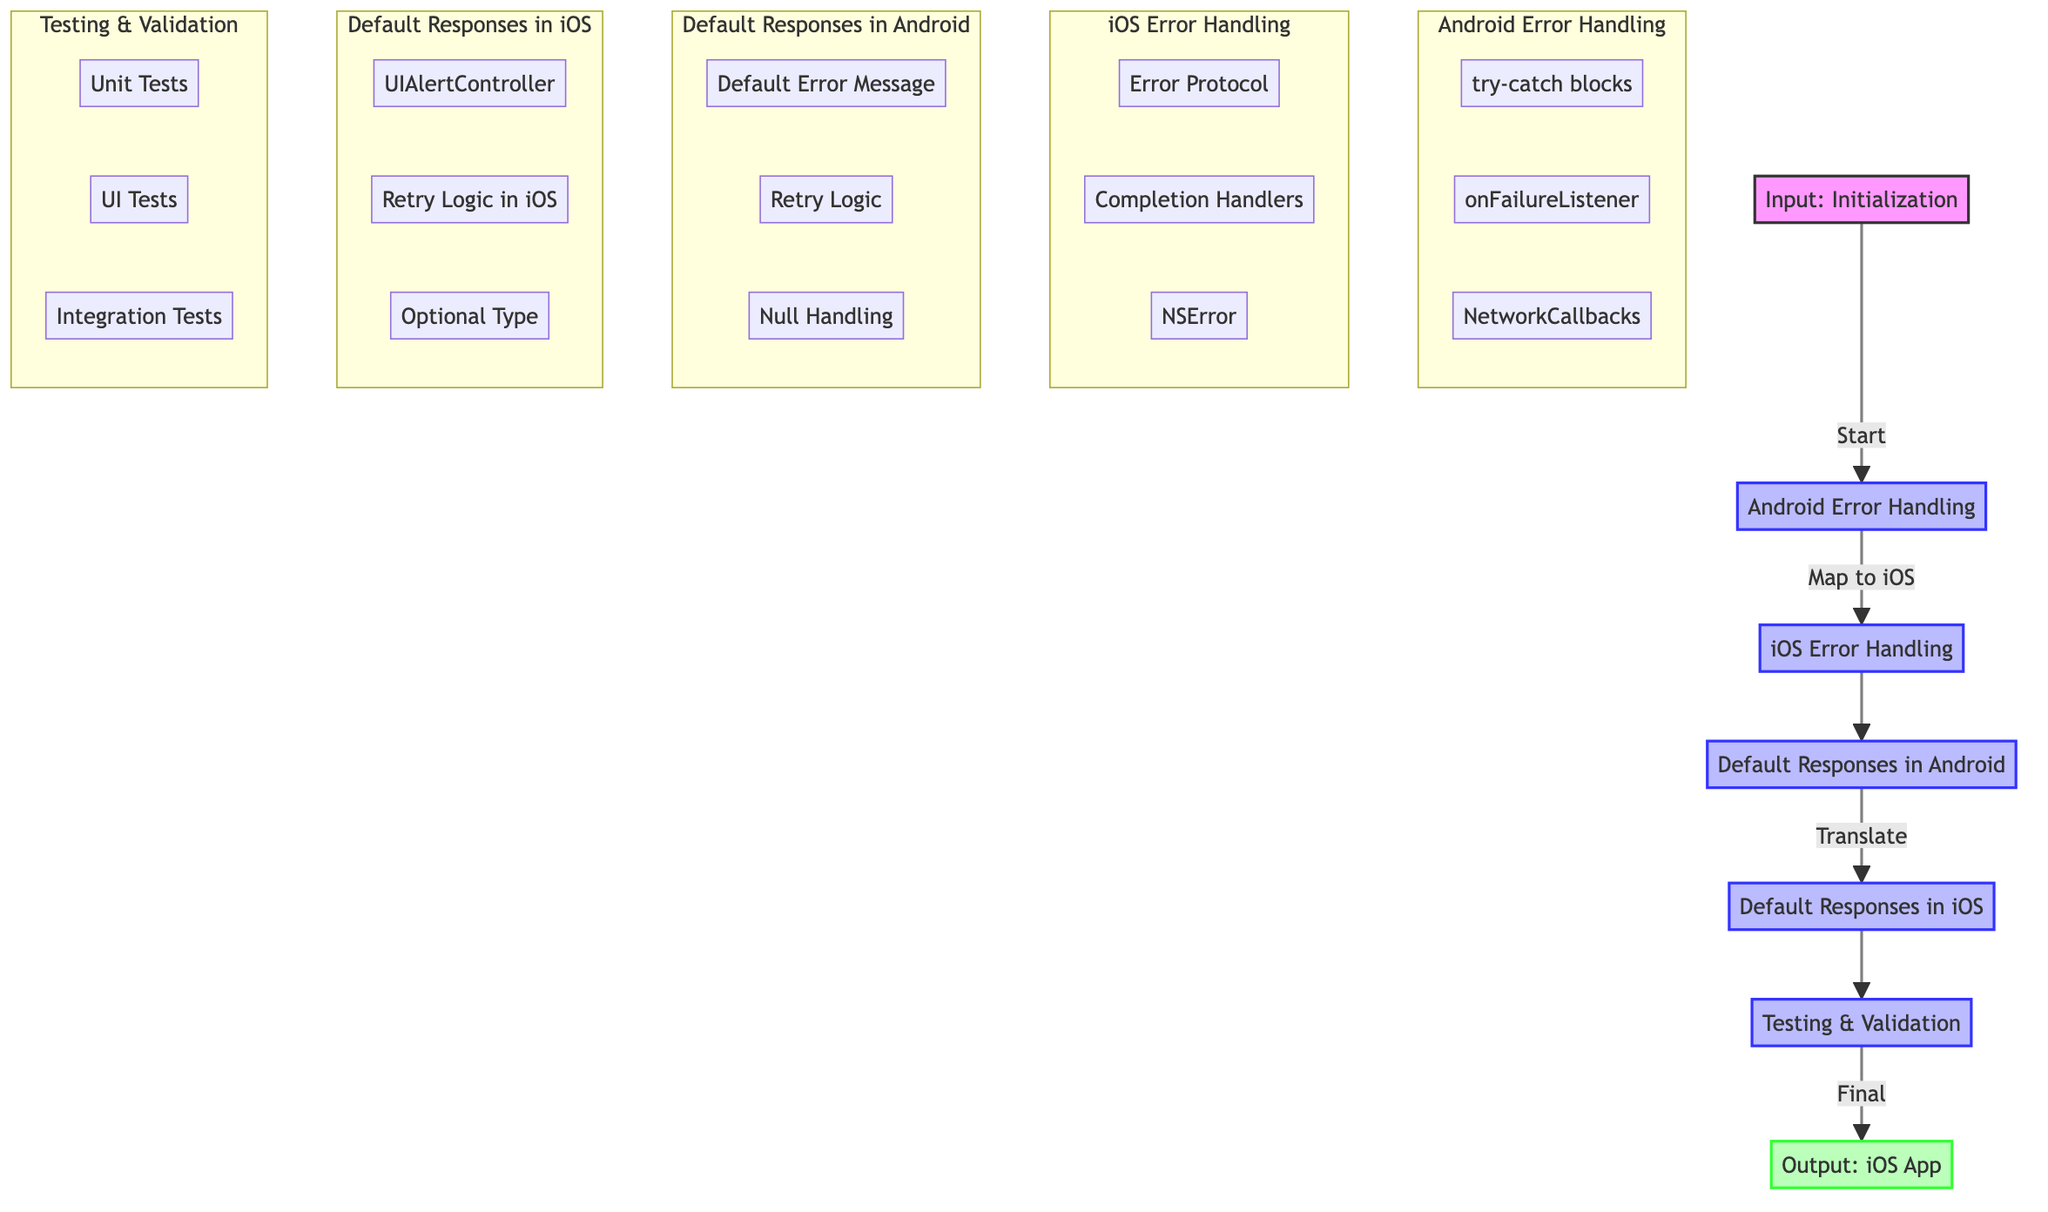What is the first step in the diagram? The first step in the diagram is represented as "Input: Initialization of the application," which is indicated as the starting node labeled 'A'.
Answer: Input: Initialization How many processes are there in the diagram? The diagram contains five processes, which are the nodes represented by 'B', 'C', 'D', 'E', and 'F'.
Answer: Five What mechanism is used for error handling in Android? The mechanism for error handling in Android is represented by "try-catch blocks," which is the first node under "Android Error Handling."
Answer: try-catch blocks What do we replace onFailureListener with in iOS? In iOS, we replace "onFailureListener" with "Completion Handlers," as indicated in the iOS error handling section.
Answer: Completion Handlers Which iOS component is used to present default error messages? The iOS component used to present default error messages is "UIAlertController," as specified in the section for Default Responses in iOS.
Answer: UIAlertController What type of testing is performed to validate user experience during errors? The type of testing performed to validate user experience during errors is "UI Tests," which is noted in the Testing & Validation section.
Answer: UI Tests How does the diagram show the transition from Android error handling to iOS? The transition from Android error handling to iOS is shown by the flow arrows connecting node 'B' (Android Error Handling) to node 'C' (iOS Error Handling).
Answer: Flow arrows What type is used in Swift to handle null values? The type used in Swift to handle null values is "Optional Type," which is mentioned under the Default Responses in iOS section.
Answer: Optional Type What follows after implementing the error handling and default responses? After implementing error handling and default responses, the next step is "Testing & Validation," as indicated by the flow from node 'E' to node 'F'.
Answer: Testing & Validation 